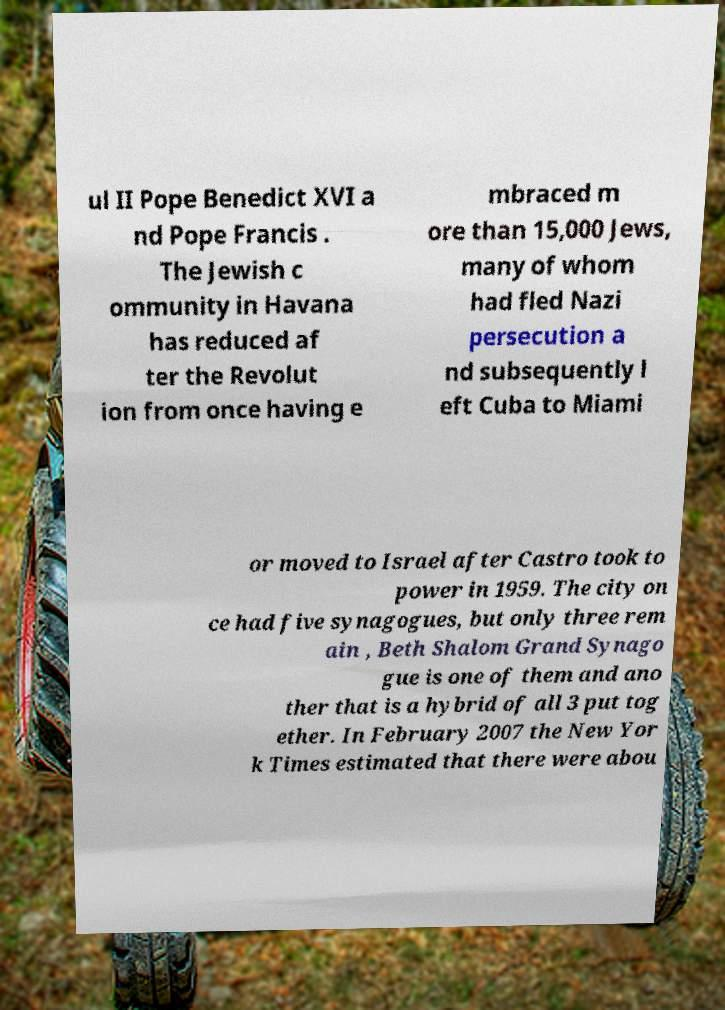I need the written content from this picture converted into text. Can you do that? ul II Pope Benedict XVI a nd Pope Francis . The Jewish c ommunity in Havana has reduced af ter the Revolut ion from once having e mbraced m ore than 15,000 Jews, many of whom had fled Nazi persecution a nd subsequently l eft Cuba to Miami or moved to Israel after Castro took to power in 1959. The city on ce had five synagogues, but only three rem ain , Beth Shalom Grand Synago gue is one of them and ano ther that is a hybrid of all 3 put tog ether. In February 2007 the New Yor k Times estimated that there were abou 